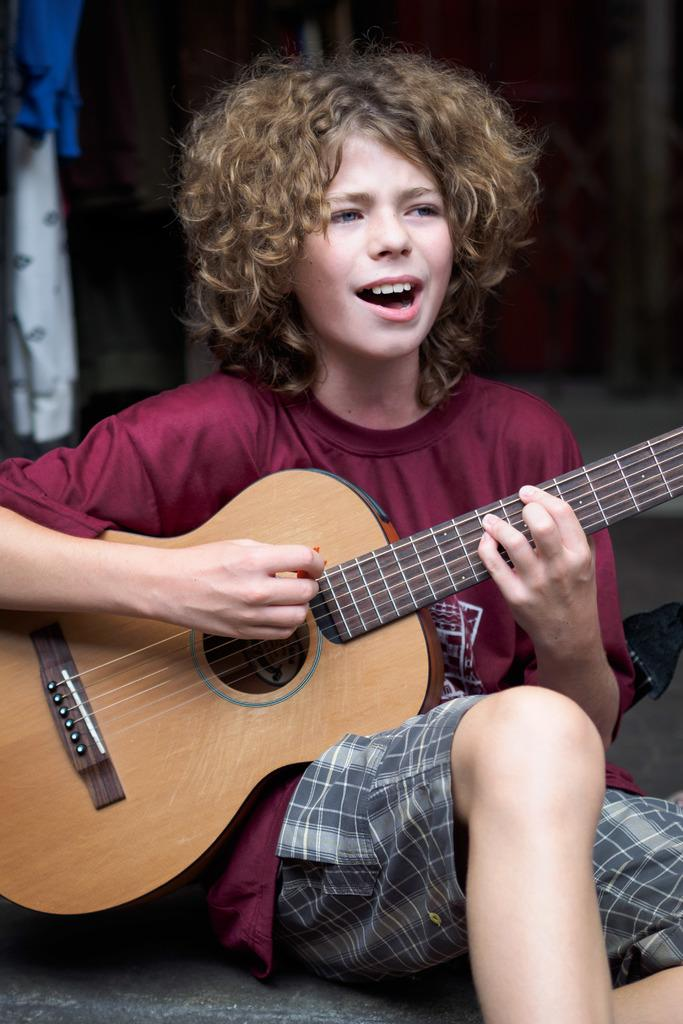Who is the main subject in the image? There is a boy in the image. What is the boy wearing? The boy is wearing a red shirt. Can you describe the boy's hairstyle? The boy has short hair. What is the boy holding in the image? The boy is holding a guitar. What is the boy doing with the guitar? The boy is playing the guitar. What type of destruction is the boy causing in the image? There is no destruction present in the image; the boy is playing the guitar. What team does the boy belong to in the image? There is no team mentioned or depicted in the image; it is a boy playing a guitar. 